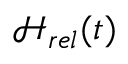Convert formula to latex. <formula><loc_0><loc_0><loc_500><loc_500>\mathcal { H } _ { r e l } ( t )</formula> 